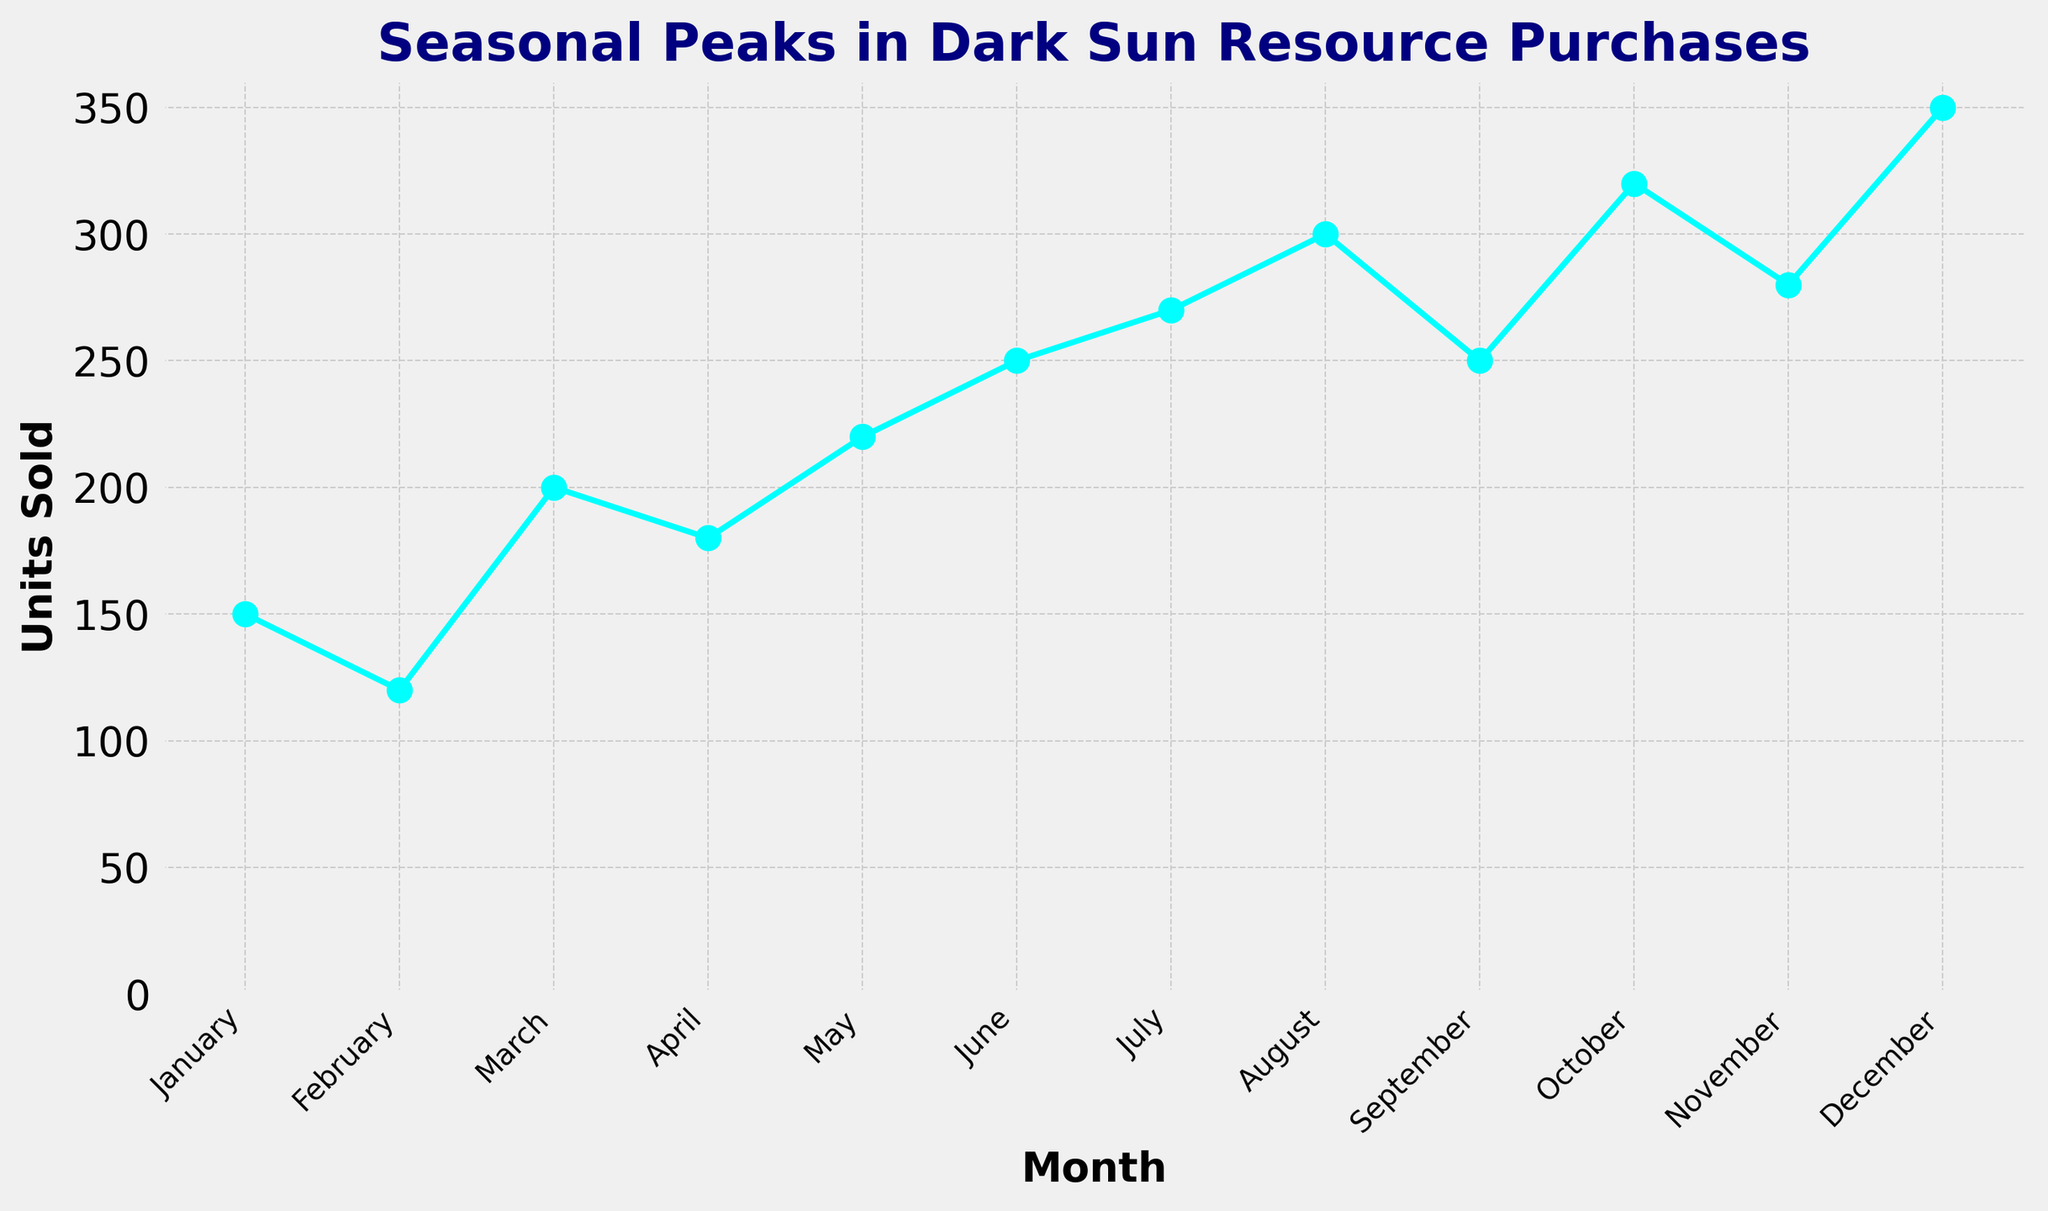What's the total number of units sold in the first quarter (January to March)? To find the total units sold in the first quarter, add the units sold in January, February, and March: 150 (January) + 120 (February) + 200 (March) = 470
Answer: 470 In which month were the most units sold and how many were sold? By examining the plot, identify the peak point (highest value). The peak occurs in December with 350 units sold.
Answer: December, 350 By how many units do December's sales exceed March's sales? To find the difference in units sold, subtract the units sold in March from the units sold in December: 350 (December) - 200 (March) = 150
Answer: 150 Which month experiences the lowest sales and what is the corresponding value? By looking at the lowest point on the graph, it's observed that February has the lowest value with 120 units sold.
Answer: February, 120 Which two consecutive months show the largest increase in units sold? Examine the slope between each pair of adjacent months. The largest increase is between July (270) and August (300): 300 - 270 = 30 units.
Answer: July to August What is the average number of units sold from June to August? To calculate the average, sum the units sold in June, July, and August and divide by the number of months: (250 (June) + 270 (July) + 300 (August)) / 3 = 273.33
Answer: 273.33 Compare the units sold in May to those sold in November. Which month had higher sales and by how much? By comparing the two values directly from the plot: May had 220 and November had 280. November had higher sales by 280 - 220 = 60 units.
Answer: November, 60 What's the total number of units sold in the second half of the year (July to December)? Sum the units sold from July to December: 270 (July) + 300 (August) + 250 (September) + 320 (October) + 280 (November) + 350 (December) = 1770
Answer: 1770 On average, how many more units were sold each month in the second half of the year compared to the first half? Calculate the total units for each half and divide by 6. First half total: 150 + 120 + 200 + 180 + 220 + 250 = 1120. Second half total: 270 + 300 + 250 + 320 + 280 + 350 = 1770. Average difference: (1770 - 1120) / 6 = 650 / 6 = 108.33
Answer: 108.33 Which month exhibits the steepest positive slope in sales when viewed sequentially? The steepest positive slope can be found by comparing the differences between each sequential month. The largest increase in one month is between November (280) and December (350), with an increase of 70 units.
Answer: November to December 